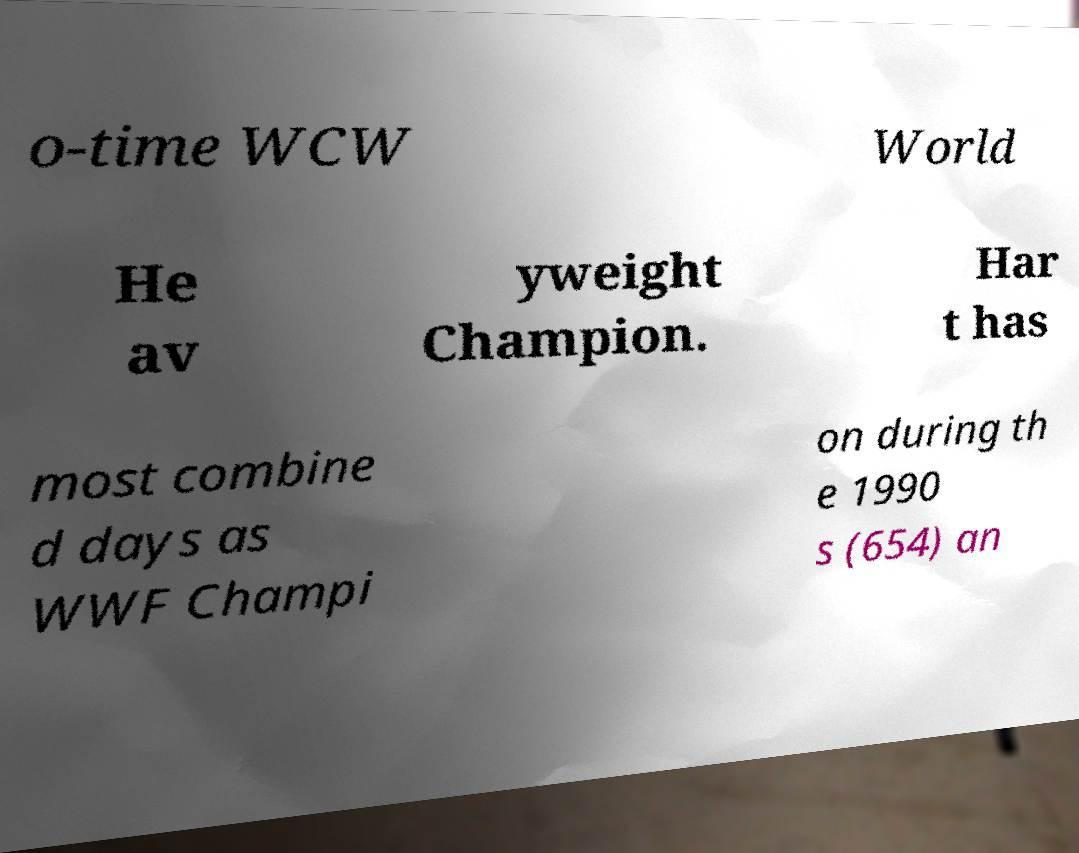Please identify and transcribe the text found in this image. o-time WCW World He av yweight Champion. Har t has most combine d days as WWF Champi on during th e 1990 s (654) an 